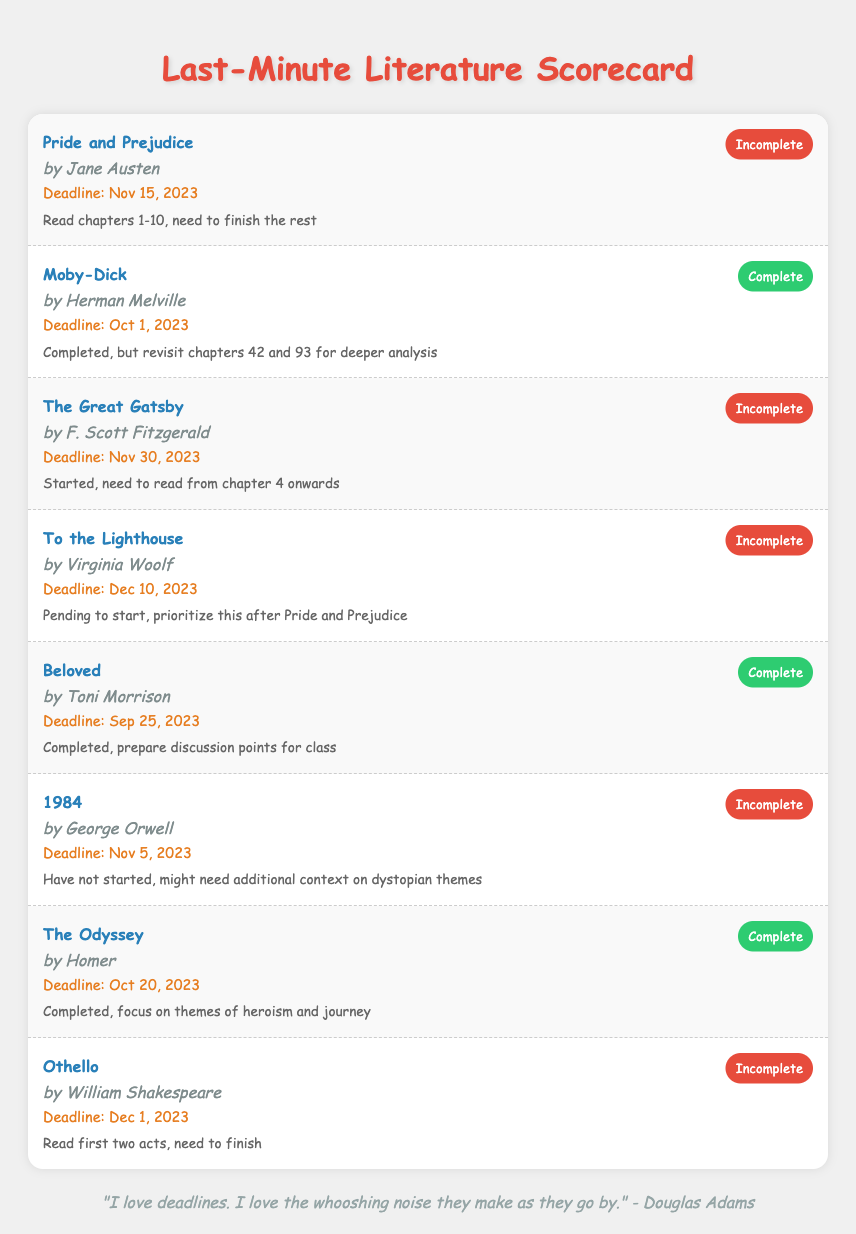What is the deadline for "Pride and Prejudice"? The deadline for "Pride and Prejudice" can be found in the "Deadline" section of the document.
Answer: Nov 15, 2023 Who is the author of "1984"? The author of "1984" is mentioned in the document associated with the book title.
Answer: George Orwell What is the completion status of "The Great Gatsby"? The completion status is displayed next to the book title in the scorecard.
Answer: Incomplete How many books are marked as complete? Count the number of books with the status "Complete" in the scorecard.
Answer: 4 What is the latest deadline among the incomplete books? The latest deadline requires comparing the deadlines of all incomplete books in the document.
Answer: Dec 10, 2023 Which book requires reading from chapter 4 onwards? This book is specifically mentioned in the notes section of the relevant book item in the scorecard.
Answer: The Great Gatsby What is the main theme focus for "The Odyssey"? The theme focus is outlined in the notes section under the book title in the scorecard.
Answer: themes of heroism and journey How many days are left until the deadline for "1984"? Calculate the difference between the current date and the deadline stated in the document.
Answer: 7 days 